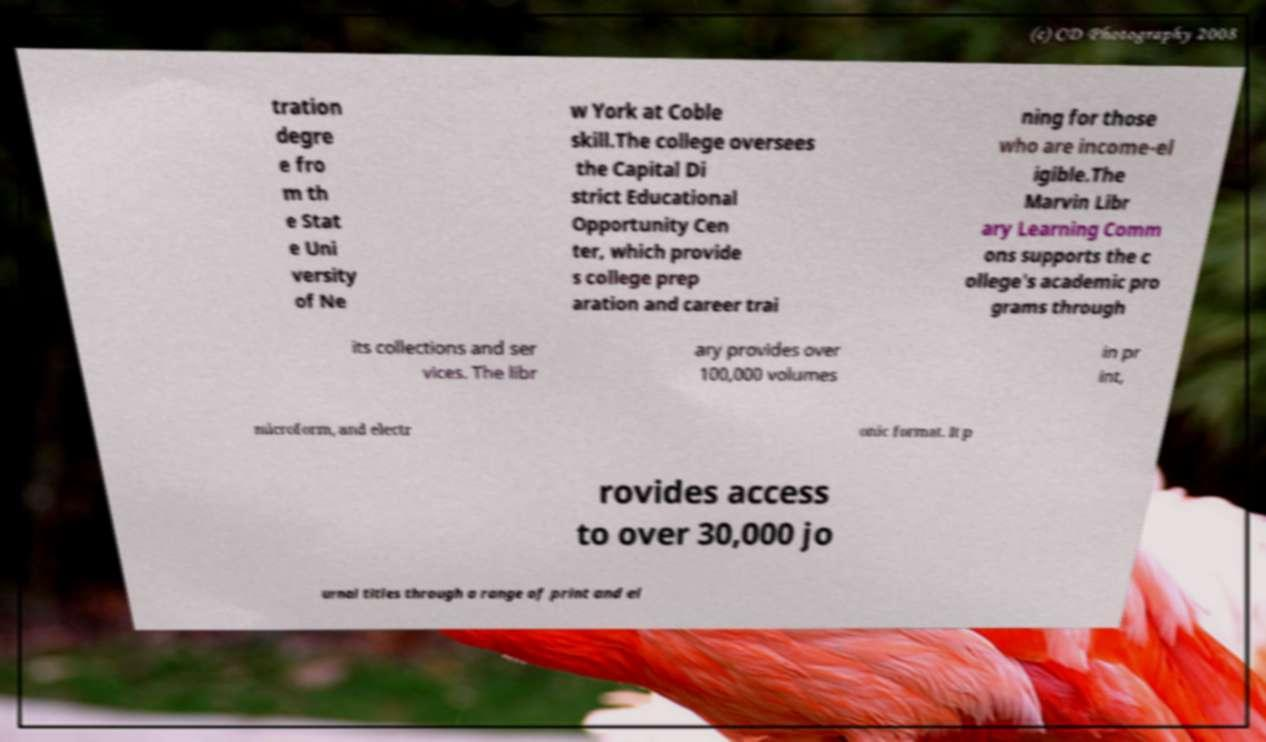There's text embedded in this image that I need extracted. Can you transcribe it verbatim? tration degre e fro m th e Stat e Uni versity of Ne w York at Coble skill.The college oversees the Capital Di strict Educational Opportunity Cen ter, which provide s college prep aration and career trai ning for those who are income-el igible.The Marvin Libr ary Learning Comm ons supports the c ollege's academic pro grams through its collections and ser vices. The libr ary provides over 100,000 volumes in pr int, microform, and electr onic format. It p rovides access to over 30,000 jo urnal titles through a range of print and el 